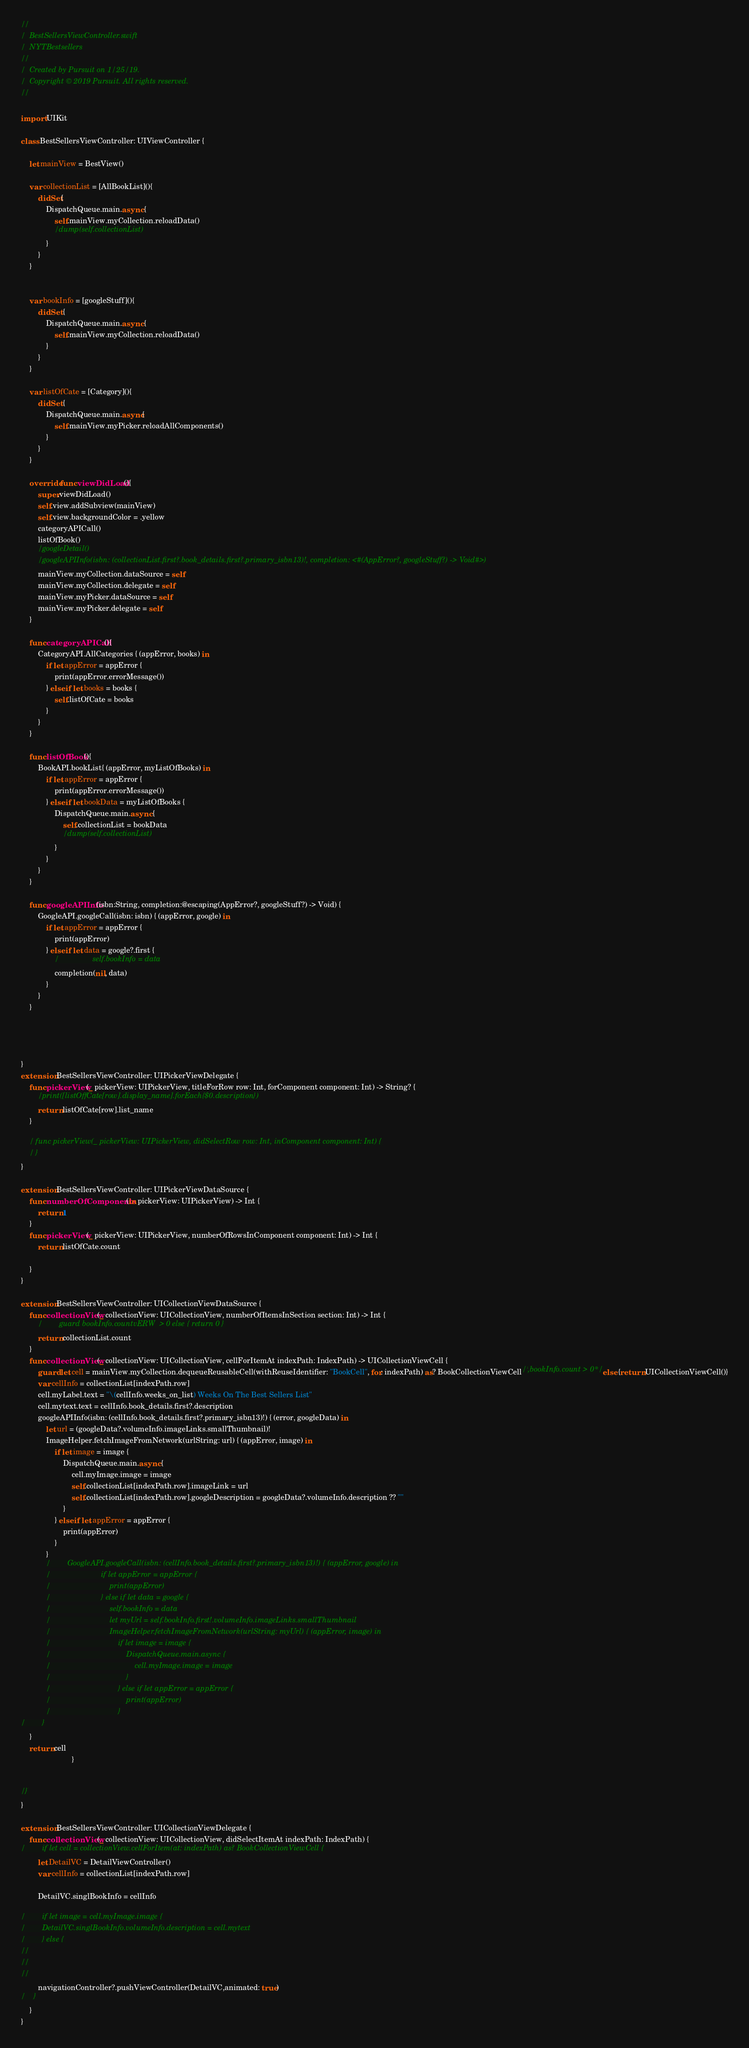<code> <loc_0><loc_0><loc_500><loc_500><_Swift_>//
//  BestSellersViewController.swift
//  NYTBestsellers
//
//  Created by Pursuit on 1/25/19.
//  Copyright © 2019 Pursuit. All rights reserved.
//

import UIKit

class BestSellersViewController: UIViewController {
    
    let mainView = BestView()
    
    var collectionList = [AllBookList](){
        didSet{
            DispatchQueue.main.async {
                self.mainView.myCollection.reloadData()
                //dump(self.collectionList)
            }
        }
    }
    
    
    var bookInfo = [googleStuff](){
        didSet {
            DispatchQueue.main.async {
                self.mainView.myCollection.reloadData()
            }
        }
    }
    
    var listOfCate = [Category](){
        didSet {
            DispatchQueue.main.async{
                self.mainView.myPicker.reloadAllComponents()
            }
        }
    }
    
    override func viewDidLoad(){
        super.viewDidLoad()
        self.view.addSubview(mainView)
        self.view.backgroundColor = .yellow
        categoryAPICall()
        listOfBook()
        //googleDetail()
        //googleAPIInfo(isbn: (collectionList.first?.book_details.first?.primary_isbn13)!, completion: <#(AppError?, googleStuff?) -> Void#>)
        mainView.myCollection.dataSource = self
        mainView.myCollection.delegate = self
        mainView.myPicker.dataSource = self
        mainView.myPicker.delegate = self
    }
    
    func categoryAPICall(){
        CategoryAPI.AllCategories { (appError, books) in
            if let appError = appError {
                print(appError.errorMessage())
            } else if let books = books {
                self.listOfCate = books
            }
        }
    }
    
    func listOfBook(){
        BookAPI.bookList{ (appError, myListOfBooks) in
            if let appError = appError {
                print(appError.errorMessage())
            } else if let bookData = myListOfBooks {
                DispatchQueue.main.async {
                    self.collectionList = bookData
                    //dump(self.collectionList)
                }
            }
        }
    }
    
    func googleAPIInfo(isbn:String, completion:@escaping(AppError?, googleStuff?) -> Void) {
        GoogleAPI.googleCall(isbn: isbn) { (appError, google) in
            if let appError = appError {
                print(appError)
            } else if let data = google?.first {
                //                self.bookInfo = data
                completion(nil, data)
            }
        }
    }
    
    
    
    
}
extension BestSellersViewController: UIPickerViewDelegate {
    func pickerView(_ pickerView: UIPickerView, titleForRow row: Int, forComponent component: Int) -> String? {
        //print([listOffCate[row].display_name].forEach{$0.description})
        return listOfCate[row].list_name
    }
    
    // func pickerView(_ pickerView: UIPickerView, didSelectRow row: Int, inComponent component: Int) {
    // }
}

extension BestSellersViewController: UIPickerViewDataSource {
    func numberOfComponents(in pickerView: UIPickerView) -> Int {
        return 1
    }
    func pickerView(_ pickerView: UIPickerView, numberOfRowsInComponent component: Int) -> Int {
        return listOfCate.count
        
    }
}

extension BestSellersViewController: UICollectionViewDataSource {
    func collectionView(_ collectionView: UICollectionView, numberOfItemsInSection section: Int) -> Int {
        //        guard bookInfo.countvERW  > 0 else { return 0 }
        return collectionList.count
    }
    func collectionView(_ collectionView: UICollectionView, cellForItemAt indexPath: IndexPath) -> UICollectionViewCell {
        guard let cell = mainView.myCollection.dequeueReusableCell(withReuseIdentifier: "BookCell", for: indexPath) as? BookCollectionViewCell/*,bookInfo.count > 0*/ else {return UICollectionViewCell()}
        var cellInfo = collectionList[indexPath.row]
        cell.myLabel.text = "\(cellInfo.weeks_on_list) Weeks On The Best Sellers List"
        cell.mytext.text = cellInfo.book_details.first?.description
        googleAPIInfo(isbn: (cellInfo.book_details.first?.primary_isbn13)!) { (error, googleData) in
            let url = (googleData?.volumeInfo.imageLinks.smallThumbnail)!
            ImageHelper.fetchImageFromNetwork(urlString: url) { (appError, image) in
                if let image = image {
                    DispatchQueue.main.async {
                        cell.myImage.image = image
                        self.collectionList[indexPath.row].imageLink = url
                        self.collectionList[indexPath.row].googleDescription = googleData?.volumeInfo.description ?? ""
                    }
                } else if let appError = appError {
                    print(appError)
                }
            }
            //        GoogleAPI.googleCall(isbn: (cellInfo.book_details.first?.primary_isbn13)!) { (appError, google) in
            //                        if let appError = appError {
            //                            print(appError)
            //                        } else if let data = google {
            //                            self.bookInfo = data
            //                            let myUrl = self.bookInfo.first!.volumeInfo.imageLinks.smallThumbnail
            //                            ImageHelper.fetchImageFromNetwork(urlString: myUrl) { (appError, image) in
            //                                if let image = image {
            //                                    DispatchQueue.main.async {
            //                                        cell.myImage.image = image
            //                                    }
            //                                } else if let appError = appError {
            //                                    print(appError)
            //                                }
//        }
    }
    return cell
                        }
    
    
//}
}

extension BestSellersViewController: UICollectionViewDelegate {
    func collectionView(_ collectionView: UICollectionView, didSelectItemAt indexPath: IndexPath) {
//        if let cell = collectionView.cellForItem(at: indexPath) as? BookCollectionViewCell {
        let DetailVC = DetailViewController()
        var cellInfo = collectionList[indexPath.row]
        
        DetailVC.singlBookInfo = cellInfo
        
//        if let image = cell.myImage.image {
//        DetailVC.singlBookInfo.volumeInfo.description = cell.mytext
//        } else {
//
//
//
        navigationController?.pushViewController(DetailVC,animated: true)
//    }
    }
}
</code> 